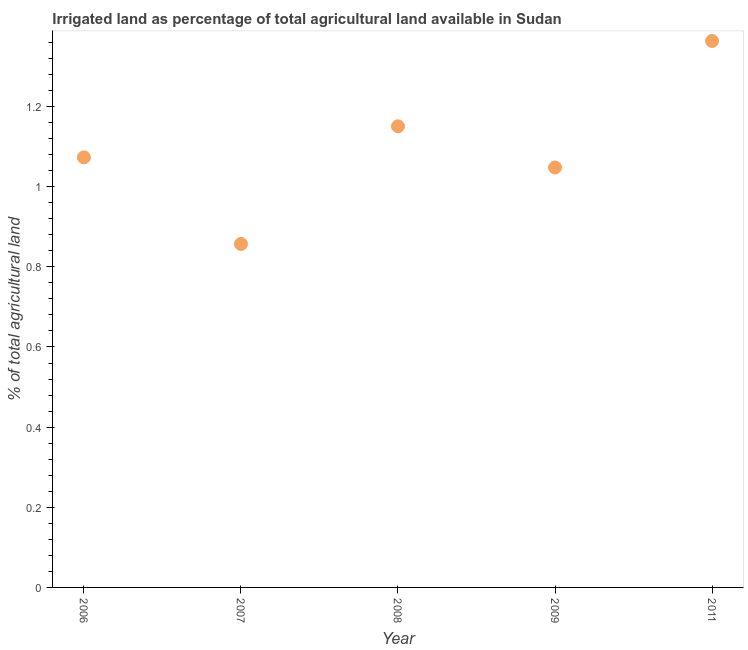What is the percentage of agricultural irrigated land in 2006?
Offer a very short reply. 1.07. Across all years, what is the maximum percentage of agricultural irrigated land?
Provide a succinct answer. 1.36. Across all years, what is the minimum percentage of agricultural irrigated land?
Your response must be concise. 0.86. In which year was the percentage of agricultural irrigated land maximum?
Your answer should be very brief. 2011. What is the sum of the percentage of agricultural irrigated land?
Give a very brief answer. 5.49. What is the difference between the percentage of agricultural irrigated land in 2006 and 2007?
Give a very brief answer. 0.22. What is the average percentage of agricultural irrigated land per year?
Provide a short and direct response. 1.1. What is the median percentage of agricultural irrigated land?
Make the answer very short. 1.07. Do a majority of the years between 2006 and 2011 (inclusive) have percentage of agricultural irrigated land greater than 1.2800000000000002 %?
Keep it short and to the point. No. What is the ratio of the percentage of agricultural irrigated land in 2006 to that in 2011?
Your answer should be compact. 0.79. Is the percentage of agricultural irrigated land in 2009 less than that in 2011?
Ensure brevity in your answer.  Yes. What is the difference between the highest and the second highest percentage of agricultural irrigated land?
Provide a short and direct response. 0.21. Is the sum of the percentage of agricultural irrigated land in 2009 and 2011 greater than the maximum percentage of agricultural irrigated land across all years?
Make the answer very short. Yes. What is the difference between the highest and the lowest percentage of agricultural irrigated land?
Your answer should be compact. 0.51. In how many years, is the percentage of agricultural irrigated land greater than the average percentage of agricultural irrigated land taken over all years?
Offer a very short reply. 2. Does the percentage of agricultural irrigated land monotonically increase over the years?
Your answer should be compact. No. How many dotlines are there?
Offer a terse response. 1. How many years are there in the graph?
Offer a very short reply. 5. Does the graph contain any zero values?
Ensure brevity in your answer.  No. Does the graph contain grids?
Offer a very short reply. No. What is the title of the graph?
Offer a terse response. Irrigated land as percentage of total agricultural land available in Sudan. What is the label or title of the X-axis?
Offer a very short reply. Year. What is the label or title of the Y-axis?
Your response must be concise. % of total agricultural land. What is the % of total agricultural land in 2006?
Offer a very short reply. 1.07. What is the % of total agricultural land in 2007?
Your answer should be very brief. 0.86. What is the % of total agricultural land in 2008?
Provide a short and direct response. 1.15. What is the % of total agricultural land in 2009?
Ensure brevity in your answer.  1.05. What is the % of total agricultural land in 2011?
Provide a short and direct response. 1.36. What is the difference between the % of total agricultural land in 2006 and 2007?
Offer a terse response. 0.22. What is the difference between the % of total agricultural land in 2006 and 2008?
Keep it short and to the point. -0.08. What is the difference between the % of total agricultural land in 2006 and 2009?
Offer a very short reply. 0.03. What is the difference between the % of total agricultural land in 2006 and 2011?
Provide a succinct answer. -0.29. What is the difference between the % of total agricultural land in 2007 and 2008?
Ensure brevity in your answer.  -0.29. What is the difference between the % of total agricultural land in 2007 and 2009?
Your answer should be compact. -0.19. What is the difference between the % of total agricultural land in 2007 and 2011?
Your answer should be very brief. -0.51. What is the difference between the % of total agricultural land in 2008 and 2009?
Your answer should be very brief. 0.1. What is the difference between the % of total agricultural land in 2008 and 2011?
Provide a short and direct response. -0.21. What is the difference between the % of total agricultural land in 2009 and 2011?
Provide a succinct answer. -0.32. What is the ratio of the % of total agricultural land in 2006 to that in 2007?
Keep it short and to the point. 1.25. What is the ratio of the % of total agricultural land in 2006 to that in 2008?
Your response must be concise. 0.93. What is the ratio of the % of total agricultural land in 2006 to that in 2011?
Provide a short and direct response. 0.79. What is the ratio of the % of total agricultural land in 2007 to that in 2008?
Provide a succinct answer. 0.74. What is the ratio of the % of total agricultural land in 2007 to that in 2009?
Your answer should be compact. 0.82. What is the ratio of the % of total agricultural land in 2007 to that in 2011?
Ensure brevity in your answer.  0.63. What is the ratio of the % of total agricultural land in 2008 to that in 2009?
Your answer should be very brief. 1.1. What is the ratio of the % of total agricultural land in 2008 to that in 2011?
Ensure brevity in your answer.  0.84. What is the ratio of the % of total agricultural land in 2009 to that in 2011?
Make the answer very short. 0.77. 